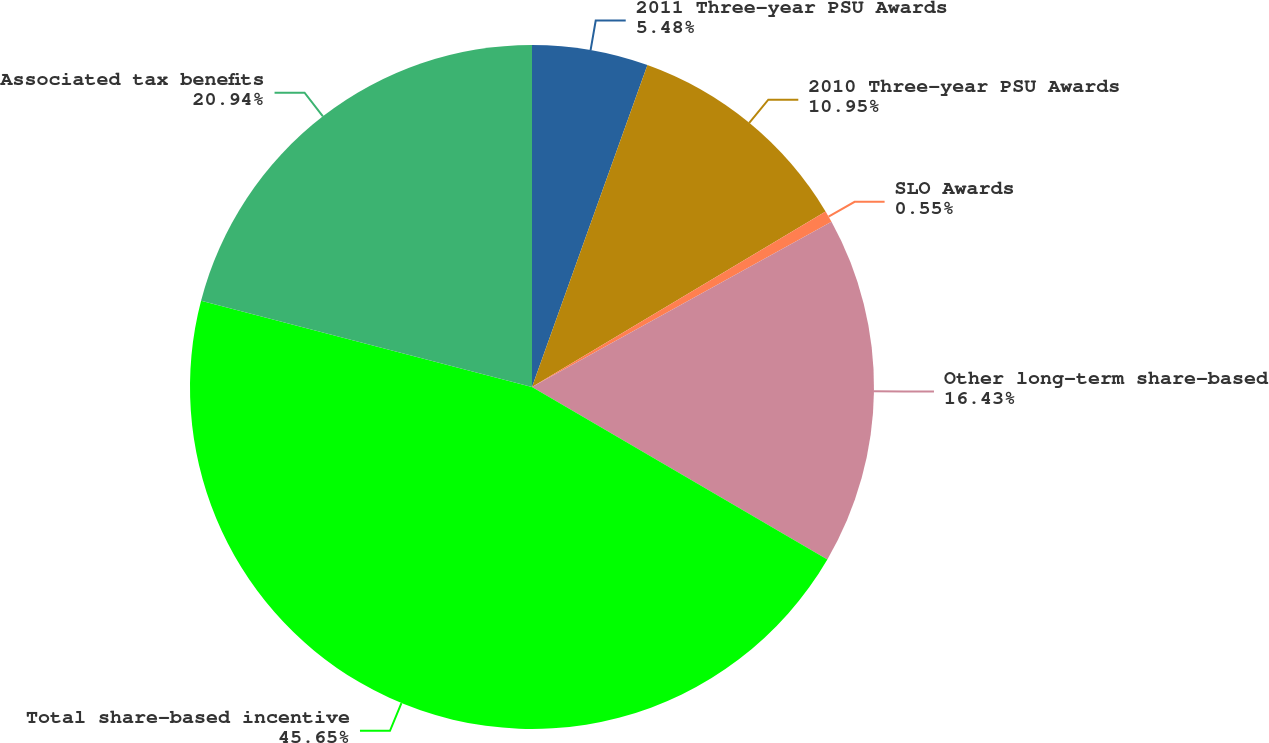Convert chart. <chart><loc_0><loc_0><loc_500><loc_500><pie_chart><fcel>2011 Three-year PSU Awards<fcel>2010 Three-year PSU Awards<fcel>SLO Awards<fcel>Other long-term share-based<fcel>Total share-based incentive<fcel>Associated tax benefits<nl><fcel>5.48%<fcel>10.95%<fcel>0.55%<fcel>16.43%<fcel>45.65%<fcel>20.94%<nl></chart> 